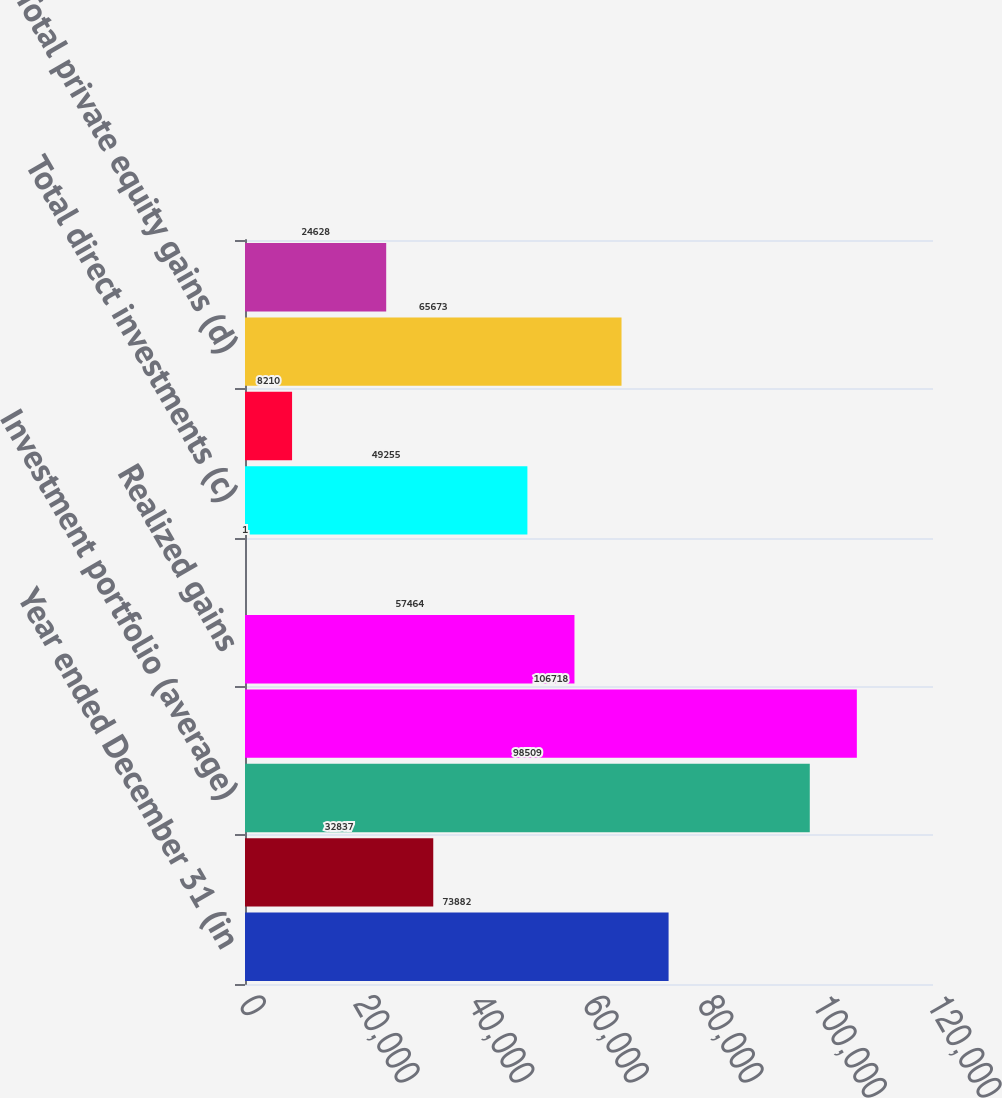Convert chart to OTSL. <chart><loc_0><loc_0><loc_500><loc_500><bar_chart><fcel>Year ended December 31 (in<fcel>Securities gains (losses) (a)<fcel>Investment portfolio (average)<fcel>Investment portfolio (ending)<fcel>Realized gains<fcel>Unrealized gains (losses)<fcel>Total direct investments (c)<fcel>Third-party fund investments<fcel>Total private equity gains (d)<fcel>Carrying value<nl><fcel>73882<fcel>32837<fcel>98509<fcel>106718<fcel>57464<fcel>1<fcel>49255<fcel>8210<fcel>65673<fcel>24628<nl></chart> 